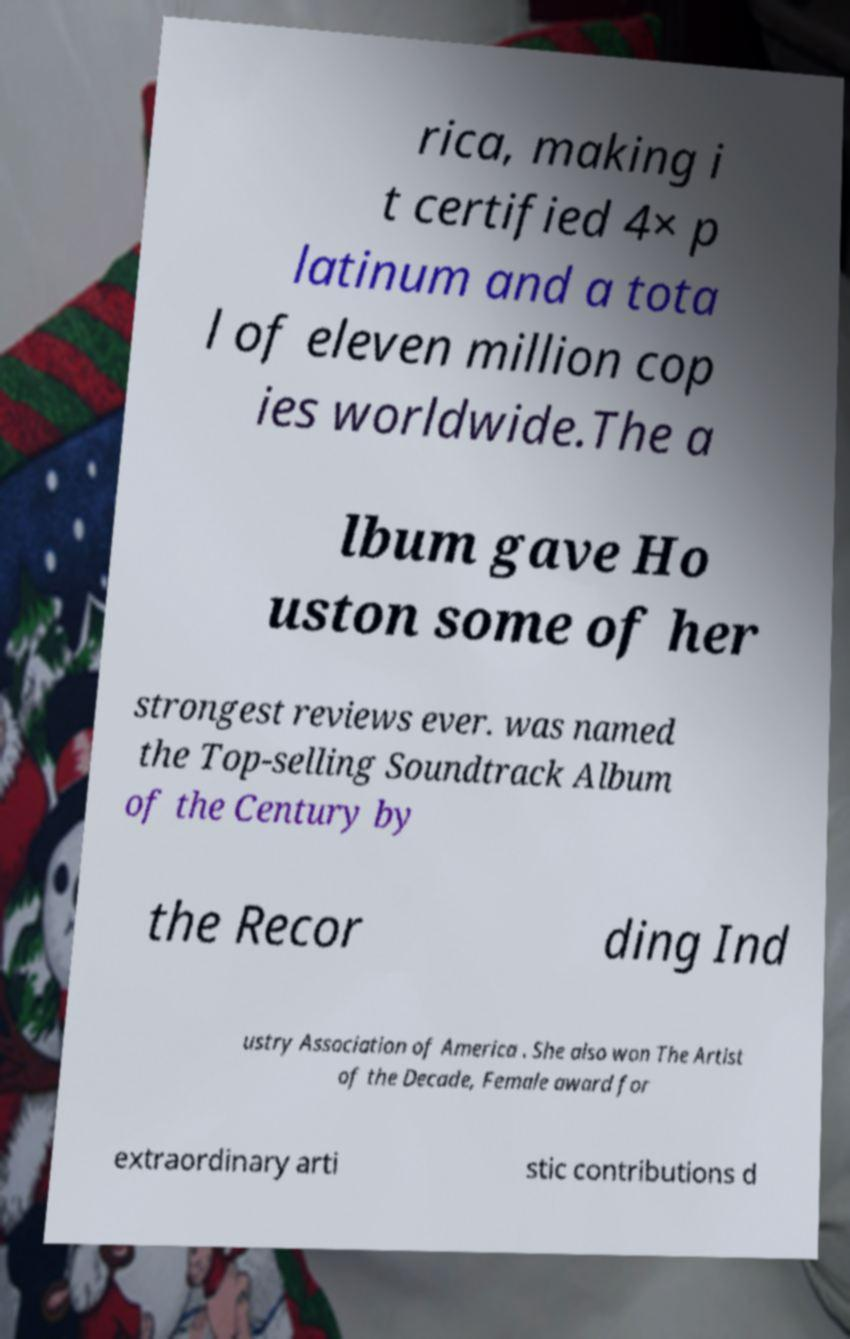Can you accurately transcribe the text from the provided image for me? rica, making i t certified 4× p latinum and a tota l of eleven million cop ies worldwide.The a lbum gave Ho uston some of her strongest reviews ever. was named the Top-selling Soundtrack Album of the Century by the Recor ding Ind ustry Association of America . She also won The Artist of the Decade, Female award for extraordinary arti stic contributions d 